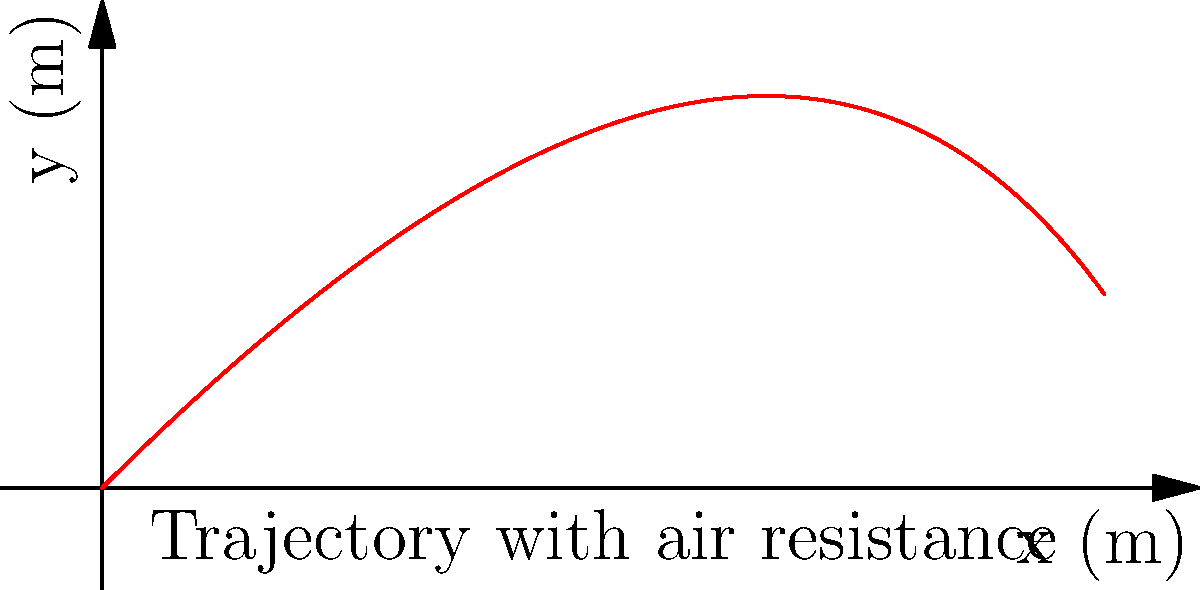Consider a projectile launched from Earth's surface with an initial velocity of 100 m/s at an angle of 45° to the horizontal. Assuming air resistance proportional to velocity with a drag coefficient of 0.1 kg/s, how does the trajectory differ from the ideal parabolic path predicted by Newtonian mechanics without air resistance? Explain the evolutionary implications of this difference for projectile-throwing organisms. To understand the trajectory difference and its evolutionary implications, let's break it down step-by-step:

1. Ideal trajectory (without air resistance):
   The path would be a perfect parabola described by:
   $$x = v_0 t \cos{\theta}$$
   $$y = v_0 t \sin{\theta} - \frac{1}{2}gt^2$$

2. Trajectory with air resistance:
   The equations of motion become:
   $$\frac{d^2x}{dt^2} = -k\frac{dx}{dt}$$
   $$\frac{d^2y}{dt^2} = -g - k\frac{dy}{dt}$$
   Where $k$ is the drag coefficient divided by mass.

3. Solving these differential equations gives:
   $$x = \frac{v_0\cos{\theta}}{k}(1-e^{-kt})$$
   $$y = \frac{v_0\sin{\theta}+g/k}{k}(1-e^{-kt}) - \frac{g}{k}t$$

4. Comparing the trajectories:
   - The path with air resistance is asymmetric and has a lower maximum height.
   - The range is significantly reduced.
   - The projectile reaches its maximum height later and descends more steeply.

5. Evolutionary implications:
   - Organisms evolving to throw projectiles would need to adapt to these real-world trajectories.
   - Natural selection would favor those who could accurately predict and compensate for air resistance.
   - This might lead to the development of:
     a) Improved spatial awareness and prediction skills
     b) Throwing techniques that minimize the effects of air resistance
     c) Projectile shapes that are more aerodynamic

6. Connection to Darwin's theory:
   - Organisms better adapted to account for air resistance in projectile motion would have a survival advantage.
   - This could lead to gradual evolutionary changes in brain structure, muscle composition, and skeletal features related to throwing.
   - The ability to accurately throw projectiles despite air resistance could have been a significant factor in human evolution, particularly in hunting and self-defense.
Answer: Air resistance causes an asymmetric, lower, and shorter trajectory, leading to evolutionary adaptations in projectile-throwing organisms for improved prediction and compensation skills. 